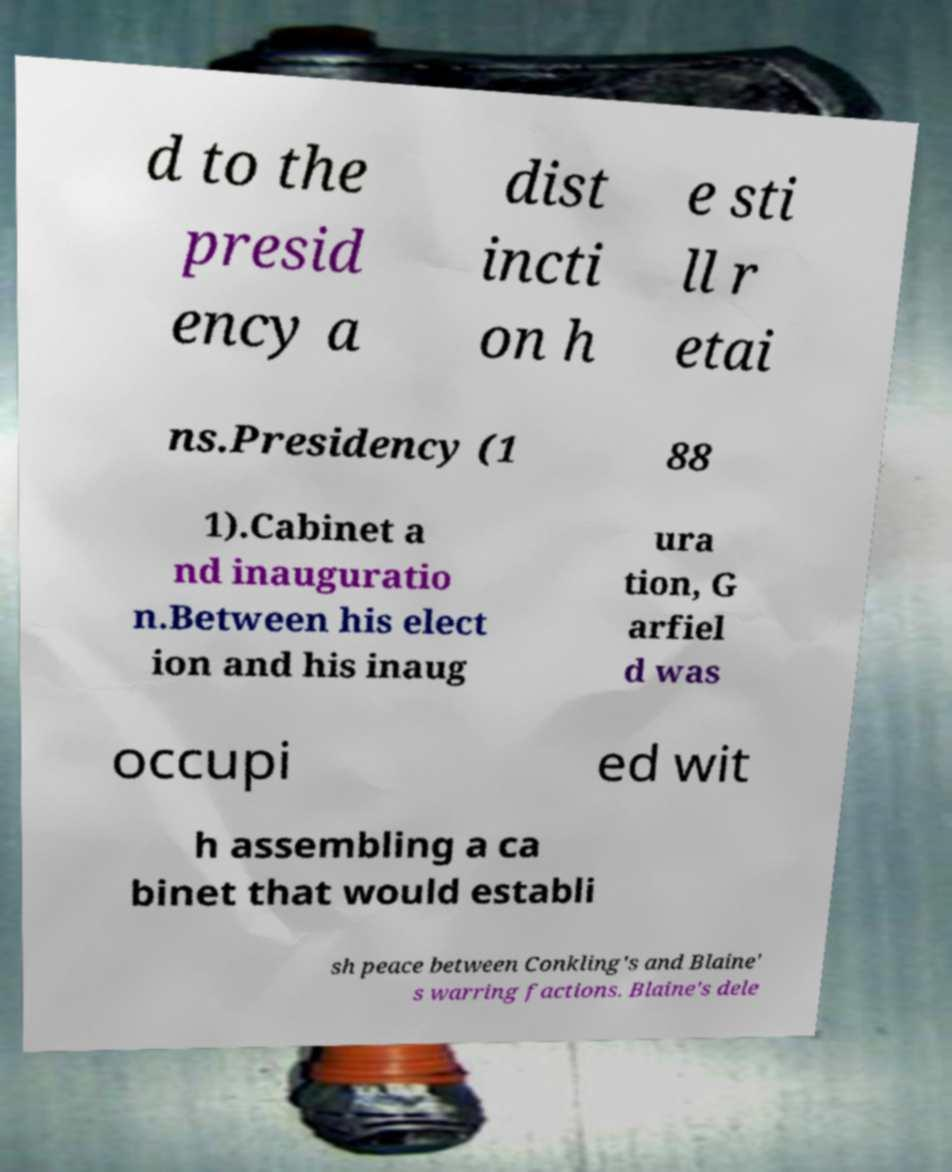Please read and relay the text visible in this image. What does it say? d to the presid ency a dist incti on h e sti ll r etai ns.Presidency (1 88 1).Cabinet a nd inauguratio n.Between his elect ion and his inaug ura tion, G arfiel d was occupi ed wit h assembling a ca binet that would establi sh peace between Conkling's and Blaine' s warring factions. Blaine's dele 